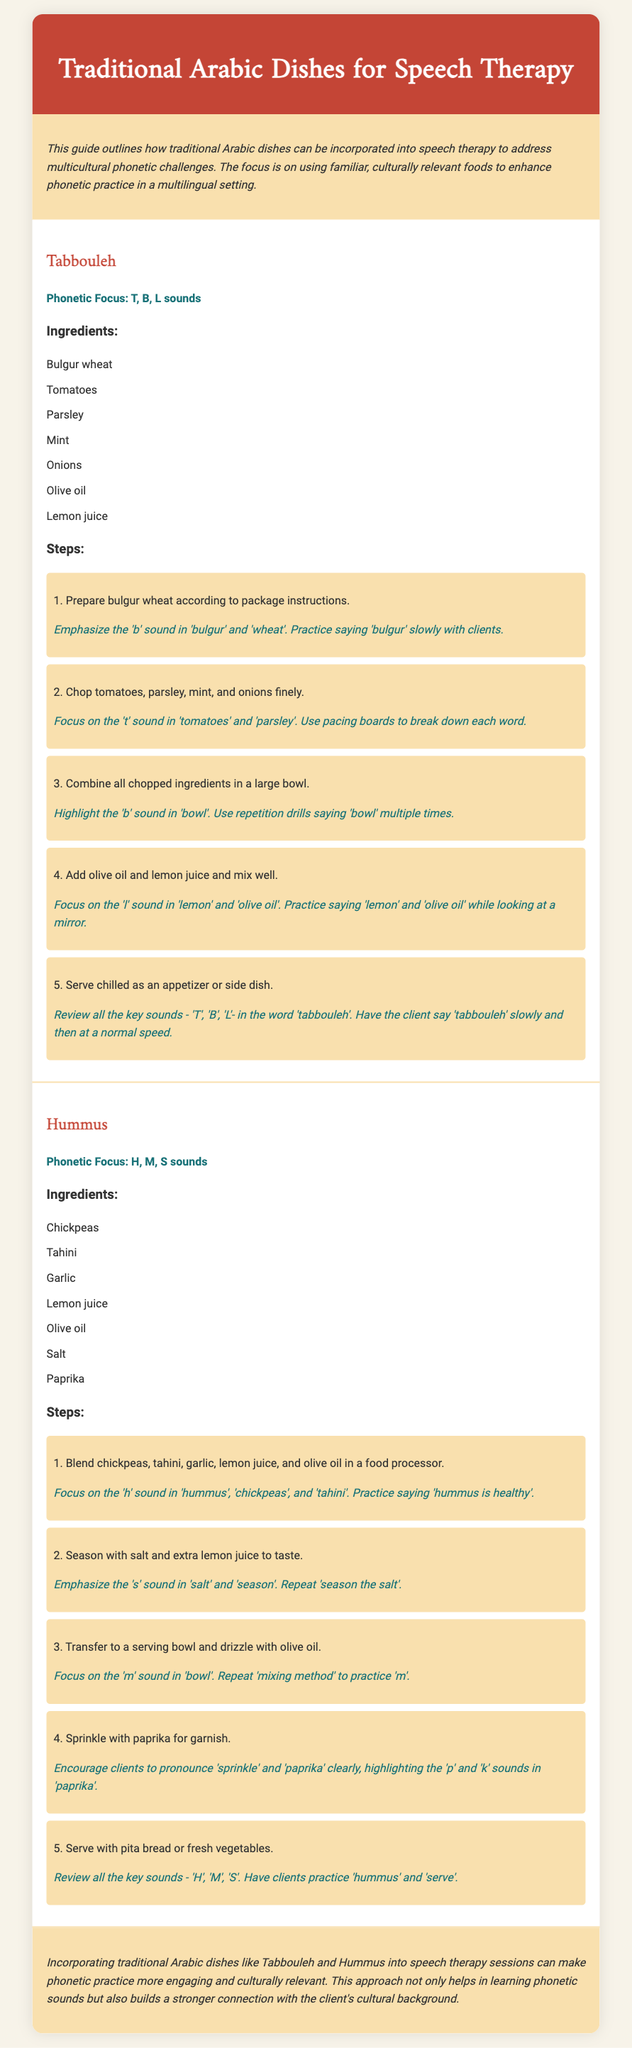what is the phonetic focus of Tabbouleh? The phonetic focus of Tabbouleh is T, B, L sounds as stated in the recipe.
Answer: T, B, L sounds how many steps are listed for Hummus? The recipe for Hummus includes five steps in total.
Answer: 5 what ingredient is used to garnish Hummus? Paprika is mentioned as the ingredient for garnish in the Hummus recipe.
Answer: Paprika which sound is emphasized in the phrase "mixing method"? The 'm' sound is highlighted in the phrase "mixing method" during the Hummus preparation.
Answer: m what is the main purpose of this document? The document aims to incorporate traditional Arabic dishes into speech therapy to enhance phonetic practice.
Answer: enhance phonetic practice 